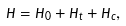<formula> <loc_0><loc_0><loc_500><loc_500>\hat { H } = \hat { H } _ { 0 } + \hat { H } _ { t } + \hat { H } _ { c } ,</formula> 